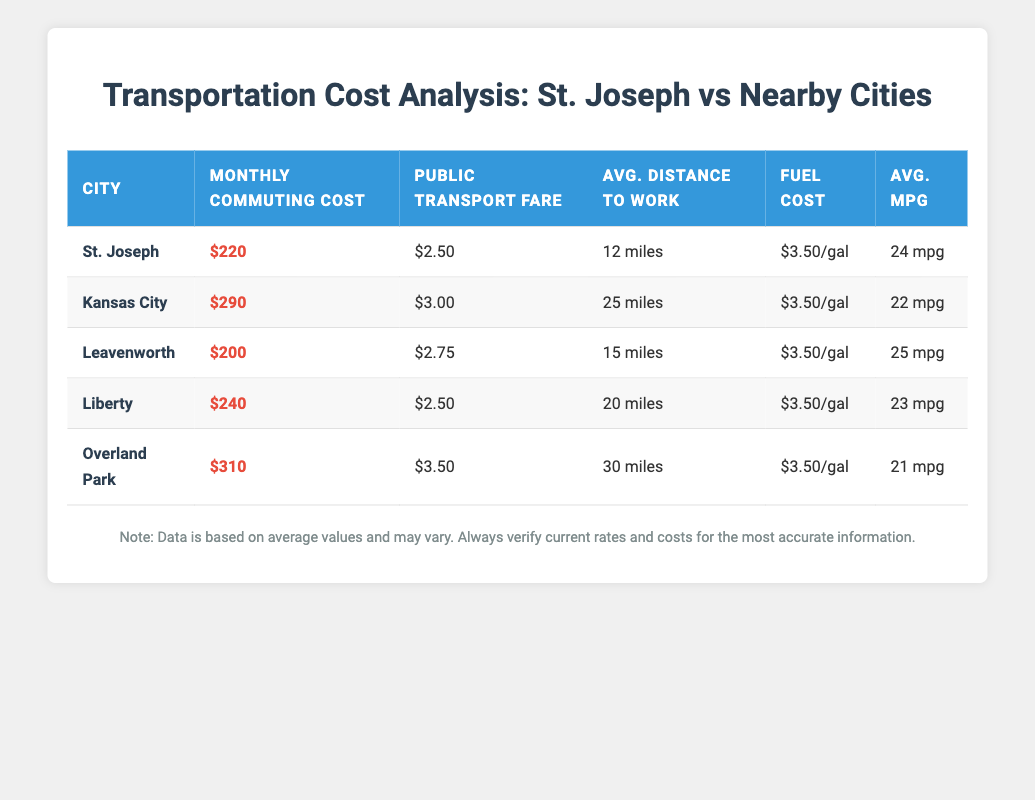What is the average monthly commuting cost in St. Joseph? The table shows that the average monthly commuting cost in St. Joseph is listed as $220.
Answer: $220 Which city has the highest average monthly commuting cost? By comparing the monthly commuting costs of each city, Overland Park at $310 has the highest cost.
Answer: Overland Park What is the public transport fare in Leavenworth? According to the table, the public transport fare in Leavenworth is $2.75.
Answer: $2.75 How much more does it cost to commute monthly in Kansas City compared to St. Joseph? Kansas City has a monthly commuting cost of $290 while St. Joseph’s cost is $220. The difference is $290 - $220 = $70.
Answer: $70 Is the average distance to work in St. Joseph greater than in Liberty? St. Joseph has an average distance to work of 12 miles and Liberty has 20 miles. Since 12 is not greater than 20, the statement is false.
Answer: No Which city has the lowest public transport fare? The table indicates that both St. Joseph and Liberty have a public transport fare of $2.50, which is the lowest compared to other cities.
Answer: St. Joseph and Liberty What is the average fuel cost per gallon across all cities? All cities have the same fuel cost per gallon of $3.50. Since they all share this value, the average is also $3.50.
Answer: $3.50 If you were to drive to work in Kansas City, how many gallons of fuel would you typically need per month? The average distance to work in Kansas City is 25 miles. With an average fuel economy of 22 mpg, you can calculate monthly fuel needs. Since commuting is assumed to be round trip and typically 20 workdays in a month, total distance is 25 miles * 2 * 20 = 1000 miles. Then, dividing by the mpg gives 1000 miles / 22 mpg = approximately 45.45 gallons needed per month.
Answer: 45.45 gallons What is the average monthly commuting cost among the cities listed? To find the average, you can add all the monthly commuting costs: (220 + 290 + 200 + 240 + 310) = 1260, then divide by the number of cities (5). 1260 / 5 = 252.
Answer: $252 